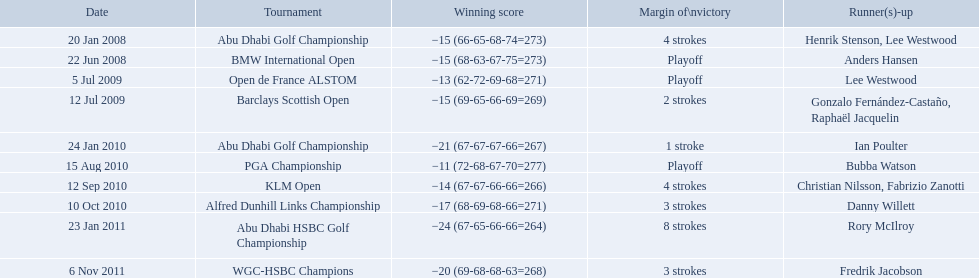What were the margins of victories of the tournaments? 4 strokes, Playoff, Playoff, 2 strokes, 1 stroke, Playoff, 4 strokes, 3 strokes, 8 strokes, 3 strokes. Of these, what was the margin of victory of the klm and the barklay 2 strokes, 4 strokes. What were the difference between these? 2 strokes. What were all of the tournaments martin played in? Abu Dhabi Golf Championship, BMW International Open, Open de France ALSTOM, Barclays Scottish Open, Abu Dhabi Golf Championship, PGA Championship, KLM Open, Alfred Dunhill Links Championship, Abu Dhabi HSBC Golf Championship, WGC-HSBC Champions. And how many strokes did he score? −15 (66-65-68-74=273), −15 (68-63-67-75=273), −13 (62-72-69-68=271), −15 (69-65-66-69=269), −21 (67-67-67-66=267), −11 (72-68-67-70=277), −14 (67-67-66-66=266), −17 (68-69-68-66=271), −24 (67-65-66-66=264), −20 (69-68-68-63=268). What about during barclays and klm? −15 (69-65-66-69=269), −14 (67-67-66-66=266). Could you parse the entire table as a dict? {'header': ['Date', 'Tournament', 'Winning score', 'Margin of\\nvictory', 'Runner(s)-up'], 'rows': [['20 Jan 2008', 'Abu Dhabi Golf Championship', '−15 (66-65-68-74=273)', '4 strokes', 'Henrik Stenson, Lee Westwood'], ['22 Jun 2008', 'BMW International Open', '−15 (68-63-67-75=273)', 'Playoff', 'Anders Hansen'], ['5 Jul 2009', 'Open de France ALSTOM', '−13 (62-72-69-68=271)', 'Playoff', 'Lee Westwood'], ['12 Jul 2009', 'Barclays Scottish Open', '−15 (69-65-66-69=269)', '2 strokes', 'Gonzalo Fernández-Castaño, Raphaël Jacquelin'], ['24 Jan 2010', 'Abu Dhabi Golf Championship', '−21 (67-67-67-66=267)', '1 stroke', 'Ian Poulter'], ['15 Aug 2010', 'PGA Championship', '−11 (72-68-67-70=277)', 'Playoff', 'Bubba Watson'], ['12 Sep 2010', 'KLM Open', '−14 (67-67-66-66=266)', '4 strokes', 'Christian Nilsson, Fabrizio Zanotti'], ['10 Oct 2010', 'Alfred Dunhill Links Championship', '−17 (68-69-68-66=271)', '3 strokes', 'Danny Willett'], ['23 Jan 2011', 'Abu Dhabi HSBC Golf Championship', '−24 (67-65-66-66=264)', '8 strokes', 'Rory McIlroy'], ['6 Nov 2011', 'WGC-HSBC Champions', '−20 (69-68-68-63=268)', '3 strokes', 'Fredrik Jacobson']]} How many more were scored in klm? 2 strokes. What are all of the tournaments? Abu Dhabi Golf Championship, BMW International Open, Open de France ALSTOM, Barclays Scottish Open, Abu Dhabi Golf Championship, PGA Championship, KLM Open, Alfred Dunhill Links Championship, Abu Dhabi HSBC Golf Championship, WGC-HSBC Champions. What was the score during each? −15 (66-65-68-74=273), −15 (68-63-67-75=273), −13 (62-72-69-68=271), −15 (69-65-66-69=269), −21 (67-67-67-66=267), −11 (72-68-67-70=277), −14 (67-67-66-66=266), −17 (68-69-68-66=271), −24 (67-65-66-66=264), −20 (69-68-68-63=268). And who was the runner-up in each? Henrik Stenson, Lee Westwood, Anders Hansen, Lee Westwood, Gonzalo Fernández-Castaño, Raphaël Jacquelin, Ian Poulter, Bubba Watson, Christian Nilsson, Fabrizio Zanotti, Danny Willett, Rory McIlroy, Fredrik Jacobson. What about just during pga games? Bubba Watson. 